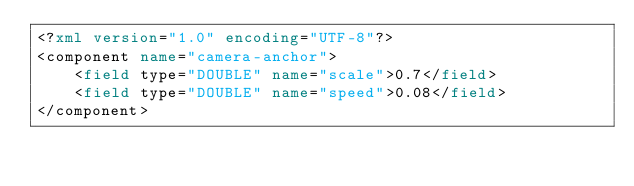Convert code to text. <code><loc_0><loc_0><loc_500><loc_500><_XML_><?xml version="1.0" encoding="UTF-8"?>
<component name="camera-anchor">
	<field type="DOUBLE" name="scale">0.7</field>
	<field type="DOUBLE" name="speed">0.08</field>
</component></code> 